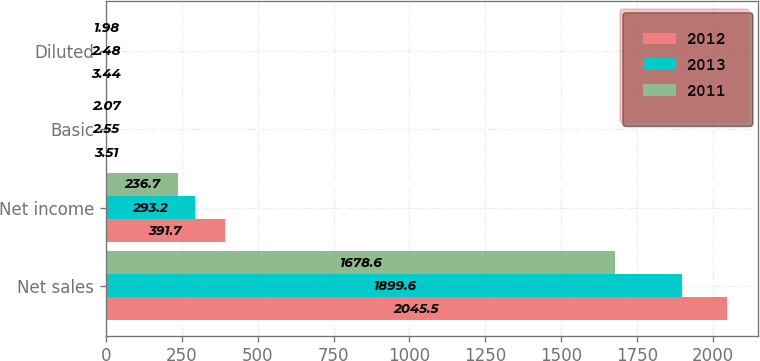Convert chart to OTSL. <chart><loc_0><loc_0><loc_500><loc_500><stacked_bar_chart><ecel><fcel>Net sales<fcel>Net income<fcel>Basic<fcel>Diluted<nl><fcel>2012<fcel>2045.5<fcel>391.7<fcel>3.51<fcel>3.44<nl><fcel>2013<fcel>1899.6<fcel>293.2<fcel>2.55<fcel>2.48<nl><fcel>2011<fcel>1678.6<fcel>236.7<fcel>2.07<fcel>1.98<nl></chart> 